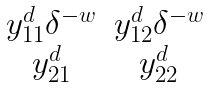Convert formula to latex. <formula><loc_0><loc_0><loc_500><loc_500>\begin{matrix} y ^ { d } _ { 1 1 } \delta ^ { - w } & y ^ { d } _ { 1 2 } \delta ^ { - w } \\ y ^ { d } _ { 2 1 } & y ^ { d } _ { 2 2 } \\ \end{matrix}</formula> 